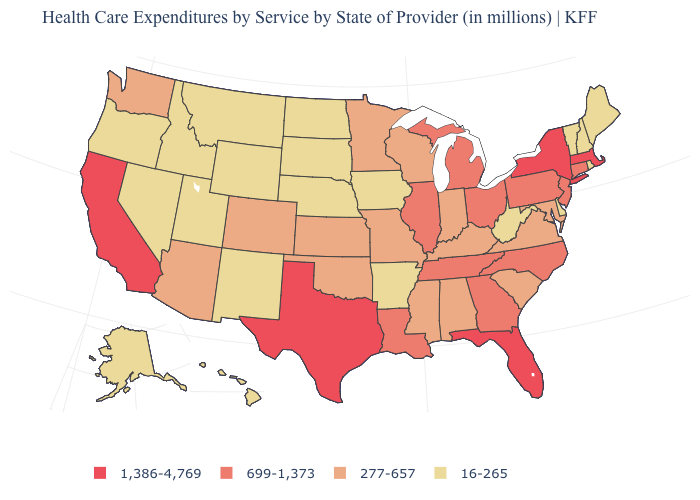Among the states that border Colorado , does Kansas have the lowest value?
Concise answer only. No. What is the value of South Dakota?
Keep it brief. 16-265. Name the states that have a value in the range 16-265?
Concise answer only. Alaska, Arkansas, Delaware, Hawaii, Idaho, Iowa, Maine, Montana, Nebraska, Nevada, New Hampshire, New Mexico, North Dakota, Oregon, Rhode Island, South Dakota, Utah, Vermont, West Virginia, Wyoming. Does Hawaii have a lower value than Washington?
Be succinct. Yes. Which states have the highest value in the USA?
Quick response, please. California, Florida, Massachusetts, New York, Texas. Among the states that border Rhode Island , which have the highest value?
Give a very brief answer. Massachusetts. Does Vermont have the same value as Louisiana?
Give a very brief answer. No. What is the lowest value in states that border Georgia?
Answer briefly. 277-657. Is the legend a continuous bar?
Write a very short answer. No. Name the states that have a value in the range 1,386-4,769?
Short answer required. California, Florida, Massachusetts, New York, Texas. Does Oregon have the lowest value in the West?
Answer briefly. Yes. What is the lowest value in the West?
Keep it brief. 16-265. What is the value of New York?
Quick response, please. 1,386-4,769. Name the states that have a value in the range 277-657?
Give a very brief answer. Alabama, Arizona, Colorado, Indiana, Kansas, Kentucky, Maryland, Minnesota, Mississippi, Missouri, Oklahoma, South Carolina, Virginia, Washington, Wisconsin. Does Nebraska have the highest value in the MidWest?
Be succinct. No. 